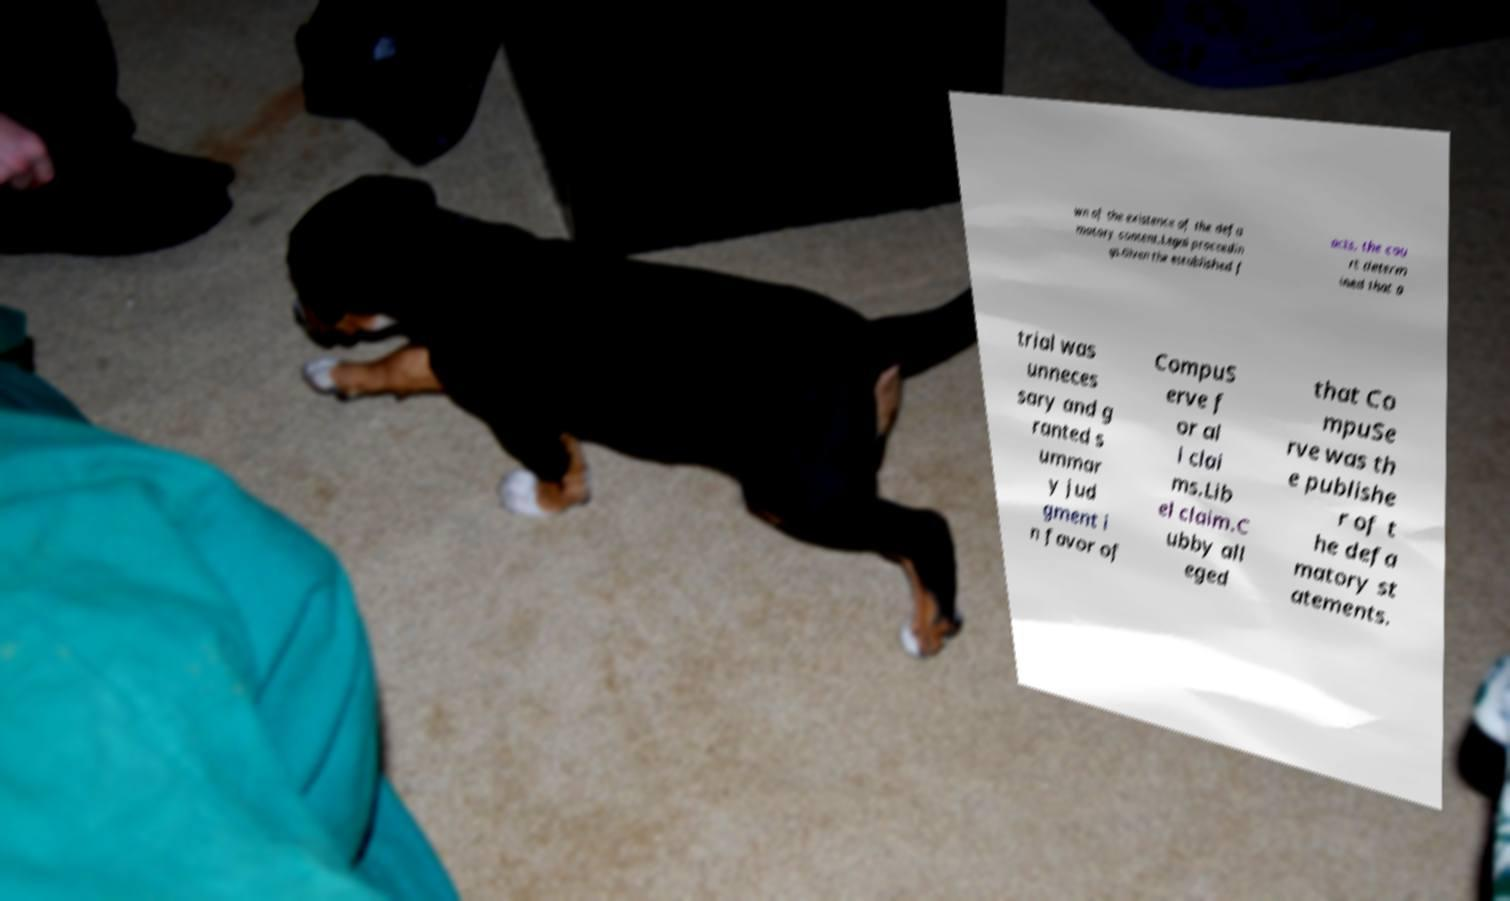For documentation purposes, I need the text within this image transcribed. Could you provide that? wn of the existence of the defa matory content.Legal proceedin gs.Given the established f acts, the cou rt determ ined that a trial was unneces sary and g ranted s ummar y jud gment i n favor of CompuS erve f or al l clai ms.Lib el claim.C ubby all eged that Co mpuSe rve was th e publishe r of t he defa matory st atements. 